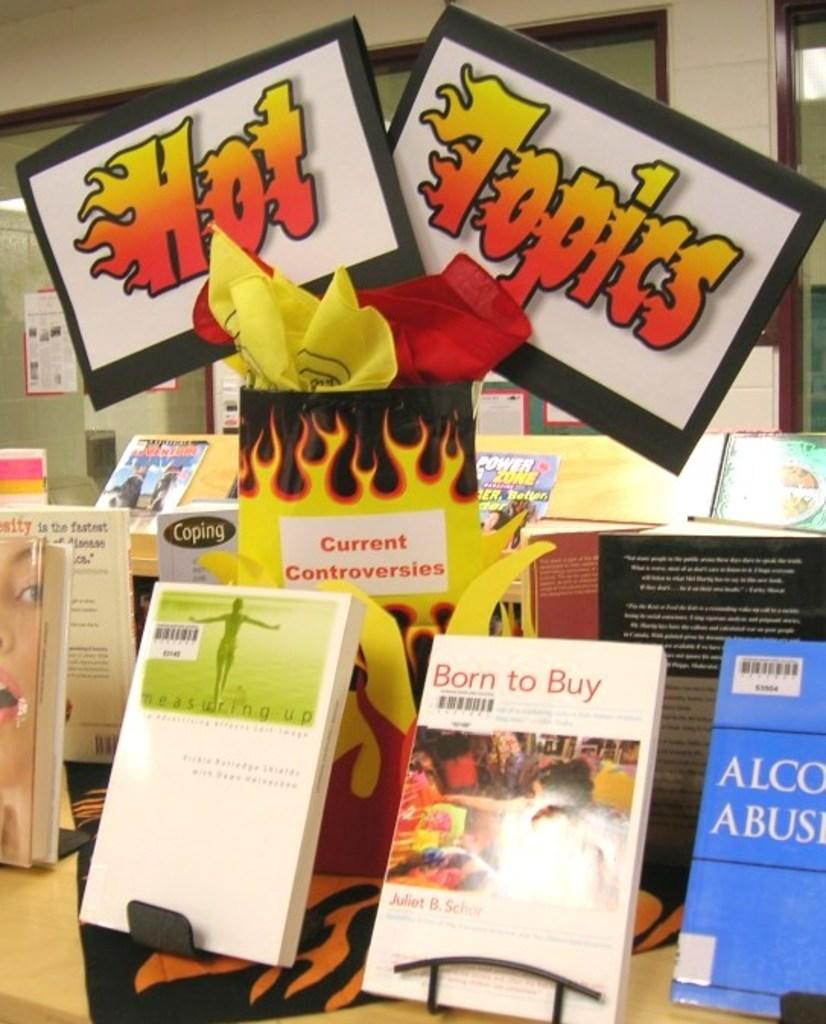Provide a one-sentence caption for the provided image. Books are on stands displayed in a store, with a sign that says Hot topics. 